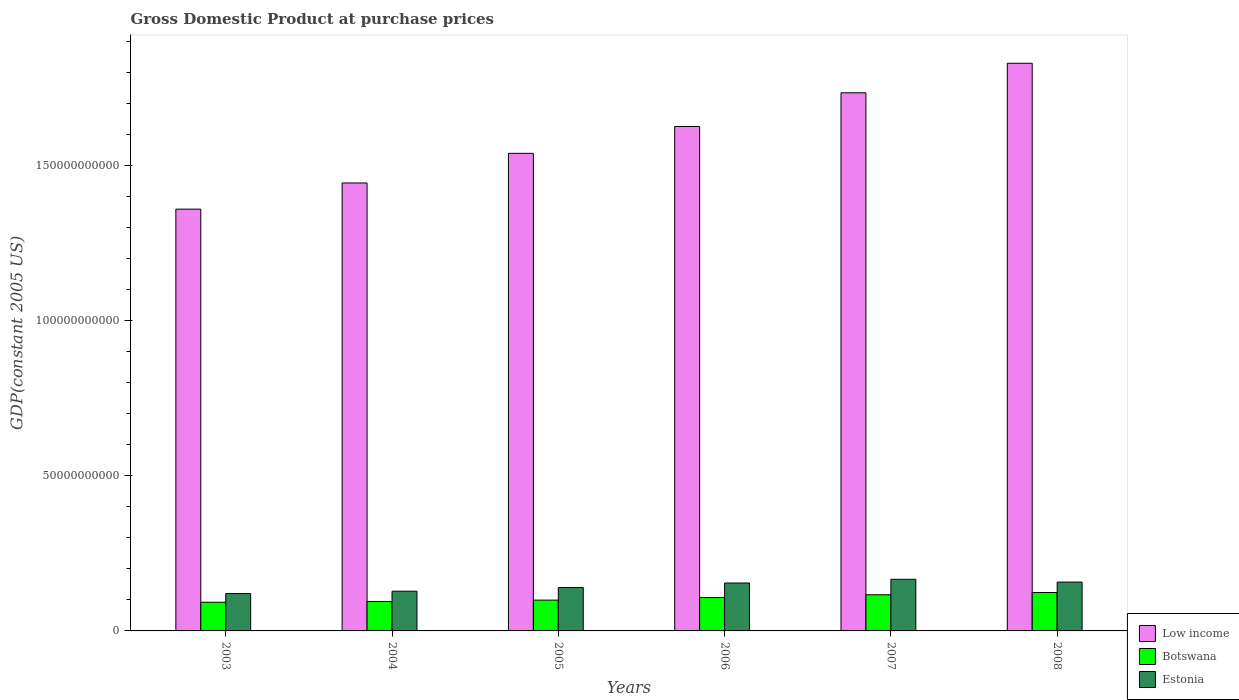How many different coloured bars are there?
Offer a terse response. 3. How many groups of bars are there?
Provide a short and direct response. 6. Are the number of bars per tick equal to the number of legend labels?
Keep it short and to the point. Yes. Are the number of bars on each tick of the X-axis equal?
Your answer should be compact. Yes. In how many cases, is the number of bars for a given year not equal to the number of legend labels?
Ensure brevity in your answer.  0. What is the GDP at purchase prices in Botswana in 2008?
Offer a very short reply. 1.24e+1. Across all years, what is the maximum GDP at purchase prices in Botswana?
Keep it short and to the point. 1.24e+1. Across all years, what is the minimum GDP at purchase prices in Botswana?
Your answer should be very brief. 9.25e+09. In which year was the GDP at purchase prices in Estonia minimum?
Keep it short and to the point. 2003. What is the total GDP at purchase prices in Estonia in the graph?
Ensure brevity in your answer.  8.67e+1. What is the difference between the GDP at purchase prices in Low income in 2003 and that in 2007?
Your answer should be very brief. -3.75e+1. What is the difference between the GDP at purchase prices in Botswana in 2007 and the GDP at purchase prices in Estonia in 2005?
Your answer should be compact. -2.35e+09. What is the average GDP at purchase prices in Botswana per year?
Ensure brevity in your answer.  1.06e+1. In the year 2005, what is the difference between the GDP at purchase prices in Low income and GDP at purchase prices in Estonia?
Ensure brevity in your answer.  1.40e+11. What is the ratio of the GDP at purchase prices in Low income in 2006 to that in 2007?
Make the answer very short. 0.94. Is the GDP at purchase prices in Low income in 2003 less than that in 2006?
Your response must be concise. Yes. What is the difference between the highest and the second highest GDP at purchase prices in Estonia?
Provide a short and direct response. 9.02e+08. What is the difference between the highest and the lowest GDP at purchase prices in Estonia?
Provide a succinct answer. 4.59e+09. Is the sum of the GDP at purchase prices in Low income in 2005 and 2006 greater than the maximum GDP at purchase prices in Botswana across all years?
Ensure brevity in your answer.  Yes. What does the 2nd bar from the left in 2005 represents?
Make the answer very short. Botswana. What does the 2nd bar from the right in 2007 represents?
Offer a very short reply. Botswana. How many years are there in the graph?
Offer a terse response. 6. Does the graph contain any zero values?
Provide a succinct answer. No. Does the graph contain grids?
Provide a short and direct response. No. How are the legend labels stacked?
Give a very brief answer. Vertical. What is the title of the graph?
Your answer should be compact. Gross Domestic Product at purchase prices. What is the label or title of the X-axis?
Your answer should be very brief. Years. What is the label or title of the Y-axis?
Give a very brief answer. GDP(constant 2005 US). What is the GDP(constant 2005 US) in Low income in 2003?
Provide a short and direct response. 1.36e+11. What is the GDP(constant 2005 US) of Botswana in 2003?
Ensure brevity in your answer.  9.25e+09. What is the GDP(constant 2005 US) in Estonia in 2003?
Provide a short and direct response. 1.20e+1. What is the GDP(constant 2005 US) of Low income in 2004?
Give a very brief answer. 1.44e+11. What is the GDP(constant 2005 US) of Botswana in 2004?
Give a very brief answer. 9.50e+09. What is the GDP(constant 2005 US) in Estonia in 2004?
Keep it short and to the point. 1.28e+1. What is the GDP(constant 2005 US) of Low income in 2005?
Your response must be concise. 1.54e+11. What is the GDP(constant 2005 US) in Botswana in 2005?
Provide a succinct answer. 9.93e+09. What is the GDP(constant 2005 US) of Estonia in 2005?
Your answer should be compact. 1.40e+1. What is the GDP(constant 2005 US) of Low income in 2006?
Your answer should be compact. 1.63e+11. What is the GDP(constant 2005 US) in Botswana in 2006?
Provide a short and direct response. 1.08e+1. What is the GDP(constant 2005 US) of Estonia in 2006?
Give a very brief answer. 1.54e+1. What is the GDP(constant 2005 US) in Low income in 2007?
Offer a very short reply. 1.73e+11. What is the GDP(constant 2005 US) in Botswana in 2007?
Offer a very short reply. 1.17e+1. What is the GDP(constant 2005 US) of Estonia in 2007?
Keep it short and to the point. 1.66e+1. What is the GDP(constant 2005 US) in Low income in 2008?
Offer a very short reply. 1.83e+11. What is the GDP(constant 2005 US) in Botswana in 2008?
Give a very brief answer. 1.24e+1. What is the GDP(constant 2005 US) of Estonia in 2008?
Provide a succinct answer. 1.57e+1. Across all years, what is the maximum GDP(constant 2005 US) of Low income?
Give a very brief answer. 1.83e+11. Across all years, what is the maximum GDP(constant 2005 US) in Botswana?
Offer a terse response. 1.24e+1. Across all years, what is the maximum GDP(constant 2005 US) in Estonia?
Make the answer very short. 1.66e+1. Across all years, what is the minimum GDP(constant 2005 US) of Low income?
Make the answer very short. 1.36e+11. Across all years, what is the minimum GDP(constant 2005 US) in Botswana?
Ensure brevity in your answer.  9.25e+09. Across all years, what is the minimum GDP(constant 2005 US) in Estonia?
Provide a succinct answer. 1.20e+1. What is the total GDP(constant 2005 US) in Low income in the graph?
Keep it short and to the point. 9.53e+11. What is the total GDP(constant 2005 US) in Botswana in the graph?
Provide a succinct answer. 6.35e+1. What is the total GDP(constant 2005 US) in Estonia in the graph?
Offer a terse response. 8.67e+1. What is the difference between the GDP(constant 2005 US) of Low income in 2003 and that in 2004?
Offer a terse response. -8.44e+09. What is the difference between the GDP(constant 2005 US) in Botswana in 2003 and that in 2004?
Your response must be concise. -2.50e+08. What is the difference between the GDP(constant 2005 US) in Estonia in 2003 and that in 2004?
Ensure brevity in your answer.  -7.58e+08. What is the difference between the GDP(constant 2005 US) in Low income in 2003 and that in 2005?
Make the answer very short. -1.80e+1. What is the difference between the GDP(constant 2005 US) of Botswana in 2003 and that in 2005?
Your answer should be compact. -6.83e+08. What is the difference between the GDP(constant 2005 US) of Estonia in 2003 and that in 2005?
Provide a short and direct response. -1.96e+09. What is the difference between the GDP(constant 2005 US) in Low income in 2003 and that in 2006?
Offer a terse response. -2.66e+1. What is the difference between the GDP(constant 2005 US) of Botswana in 2003 and that in 2006?
Give a very brief answer. -1.51e+09. What is the difference between the GDP(constant 2005 US) in Estonia in 2003 and that in 2006?
Your response must be concise. -3.40e+09. What is the difference between the GDP(constant 2005 US) in Low income in 2003 and that in 2007?
Keep it short and to the point. -3.75e+1. What is the difference between the GDP(constant 2005 US) of Botswana in 2003 and that in 2007?
Provide a short and direct response. -2.40e+09. What is the difference between the GDP(constant 2005 US) of Estonia in 2003 and that in 2007?
Your answer should be very brief. -4.59e+09. What is the difference between the GDP(constant 2005 US) of Low income in 2003 and that in 2008?
Your answer should be compact. -4.70e+1. What is the difference between the GDP(constant 2005 US) of Botswana in 2003 and that in 2008?
Ensure brevity in your answer.  -3.13e+09. What is the difference between the GDP(constant 2005 US) in Estonia in 2003 and that in 2008?
Provide a succinct answer. -3.69e+09. What is the difference between the GDP(constant 2005 US) of Low income in 2004 and that in 2005?
Ensure brevity in your answer.  -9.54e+09. What is the difference between the GDP(constant 2005 US) in Botswana in 2004 and that in 2005?
Your response must be concise. -4.33e+08. What is the difference between the GDP(constant 2005 US) in Estonia in 2004 and that in 2005?
Your answer should be very brief. -1.20e+09. What is the difference between the GDP(constant 2005 US) of Low income in 2004 and that in 2006?
Your answer should be very brief. -1.82e+1. What is the difference between the GDP(constant 2005 US) of Botswana in 2004 and that in 2006?
Provide a short and direct response. -1.26e+09. What is the difference between the GDP(constant 2005 US) in Estonia in 2004 and that in 2006?
Provide a short and direct response. -2.64e+09. What is the difference between the GDP(constant 2005 US) in Low income in 2004 and that in 2007?
Keep it short and to the point. -2.91e+1. What is the difference between the GDP(constant 2005 US) of Botswana in 2004 and that in 2007?
Give a very brief answer. -2.15e+09. What is the difference between the GDP(constant 2005 US) of Estonia in 2004 and that in 2007?
Provide a short and direct response. -3.84e+09. What is the difference between the GDP(constant 2005 US) of Low income in 2004 and that in 2008?
Your answer should be very brief. -3.86e+1. What is the difference between the GDP(constant 2005 US) in Botswana in 2004 and that in 2008?
Your answer should be very brief. -2.88e+09. What is the difference between the GDP(constant 2005 US) of Estonia in 2004 and that in 2008?
Your response must be concise. -2.93e+09. What is the difference between the GDP(constant 2005 US) of Low income in 2005 and that in 2006?
Your response must be concise. -8.66e+09. What is the difference between the GDP(constant 2005 US) of Botswana in 2005 and that in 2006?
Provide a short and direct response. -8.31e+08. What is the difference between the GDP(constant 2005 US) of Estonia in 2005 and that in 2006?
Make the answer very short. -1.44e+09. What is the difference between the GDP(constant 2005 US) in Low income in 2005 and that in 2007?
Keep it short and to the point. -1.95e+1. What is the difference between the GDP(constant 2005 US) of Botswana in 2005 and that in 2007?
Provide a short and direct response. -1.72e+09. What is the difference between the GDP(constant 2005 US) in Estonia in 2005 and that in 2007?
Your answer should be compact. -2.64e+09. What is the difference between the GDP(constant 2005 US) in Low income in 2005 and that in 2008?
Your response must be concise. -2.90e+1. What is the difference between the GDP(constant 2005 US) of Botswana in 2005 and that in 2008?
Make the answer very short. -2.45e+09. What is the difference between the GDP(constant 2005 US) of Estonia in 2005 and that in 2008?
Offer a terse response. -1.73e+09. What is the difference between the GDP(constant 2005 US) of Low income in 2006 and that in 2007?
Make the answer very short. -1.09e+1. What is the difference between the GDP(constant 2005 US) in Botswana in 2006 and that in 2007?
Offer a terse response. -8.91e+08. What is the difference between the GDP(constant 2005 US) in Estonia in 2006 and that in 2007?
Offer a very short reply. -1.20e+09. What is the difference between the GDP(constant 2005 US) of Low income in 2006 and that in 2008?
Keep it short and to the point. -2.04e+1. What is the difference between the GDP(constant 2005 US) in Botswana in 2006 and that in 2008?
Ensure brevity in your answer.  -1.62e+09. What is the difference between the GDP(constant 2005 US) of Estonia in 2006 and that in 2008?
Offer a terse response. -2.95e+08. What is the difference between the GDP(constant 2005 US) of Low income in 2007 and that in 2008?
Give a very brief answer. -9.52e+09. What is the difference between the GDP(constant 2005 US) of Botswana in 2007 and that in 2008?
Make the answer very short. -7.27e+08. What is the difference between the GDP(constant 2005 US) of Estonia in 2007 and that in 2008?
Give a very brief answer. 9.02e+08. What is the difference between the GDP(constant 2005 US) in Low income in 2003 and the GDP(constant 2005 US) in Botswana in 2004?
Make the answer very short. 1.26e+11. What is the difference between the GDP(constant 2005 US) of Low income in 2003 and the GDP(constant 2005 US) of Estonia in 2004?
Make the answer very short. 1.23e+11. What is the difference between the GDP(constant 2005 US) in Botswana in 2003 and the GDP(constant 2005 US) in Estonia in 2004?
Offer a very short reply. -3.56e+09. What is the difference between the GDP(constant 2005 US) in Low income in 2003 and the GDP(constant 2005 US) in Botswana in 2005?
Give a very brief answer. 1.26e+11. What is the difference between the GDP(constant 2005 US) of Low income in 2003 and the GDP(constant 2005 US) of Estonia in 2005?
Keep it short and to the point. 1.22e+11. What is the difference between the GDP(constant 2005 US) of Botswana in 2003 and the GDP(constant 2005 US) of Estonia in 2005?
Ensure brevity in your answer.  -4.76e+09. What is the difference between the GDP(constant 2005 US) in Low income in 2003 and the GDP(constant 2005 US) in Botswana in 2006?
Your answer should be very brief. 1.25e+11. What is the difference between the GDP(constant 2005 US) in Low income in 2003 and the GDP(constant 2005 US) in Estonia in 2006?
Give a very brief answer. 1.21e+11. What is the difference between the GDP(constant 2005 US) in Botswana in 2003 and the GDP(constant 2005 US) in Estonia in 2006?
Your response must be concise. -6.20e+09. What is the difference between the GDP(constant 2005 US) in Low income in 2003 and the GDP(constant 2005 US) in Botswana in 2007?
Provide a succinct answer. 1.24e+11. What is the difference between the GDP(constant 2005 US) of Low income in 2003 and the GDP(constant 2005 US) of Estonia in 2007?
Make the answer very short. 1.19e+11. What is the difference between the GDP(constant 2005 US) of Botswana in 2003 and the GDP(constant 2005 US) of Estonia in 2007?
Provide a succinct answer. -7.39e+09. What is the difference between the GDP(constant 2005 US) of Low income in 2003 and the GDP(constant 2005 US) of Botswana in 2008?
Provide a succinct answer. 1.24e+11. What is the difference between the GDP(constant 2005 US) in Low income in 2003 and the GDP(constant 2005 US) in Estonia in 2008?
Keep it short and to the point. 1.20e+11. What is the difference between the GDP(constant 2005 US) in Botswana in 2003 and the GDP(constant 2005 US) in Estonia in 2008?
Give a very brief answer. -6.49e+09. What is the difference between the GDP(constant 2005 US) of Low income in 2004 and the GDP(constant 2005 US) of Botswana in 2005?
Provide a short and direct response. 1.34e+11. What is the difference between the GDP(constant 2005 US) of Low income in 2004 and the GDP(constant 2005 US) of Estonia in 2005?
Ensure brevity in your answer.  1.30e+11. What is the difference between the GDP(constant 2005 US) of Botswana in 2004 and the GDP(constant 2005 US) of Estonia in 2005?
Offer a very short reply. -4.51e+09. What is the difference between the GDP(constant 2005 US) in Low income in 2004 and the GDP(constant 2005 US) in Botswana in 2006?
Keep it short and to the point. 1.34e+11. What is the difference between the GDP(constant 2005 US) in Low income in 2004 and the GDP(constant 2005 US) in Estonia in 2006?
Provide a succinct answer. 1.29e+11. What is the difference between the GDP(constant 2005 US) in Botswana in 2004 and the GDP(constant 2005 US) in Estonia in 2006?
Provide a succinct answer. -5.95e+09. What is the difference between the GDP(constant 2005 US) in Low income in 2004 and the GDP(constant 2005 US) in Botswana in 2007?
Provide a short and direct response. 1.33e+11. What is the difference between the GDP(constant 2005 US) in Low income in 2004 and the GDP(constant 2005 US) in Estonia in 2007?
Provide a succinct answer. 1.28e+11. What is the difference between the GDP(constant 2005 US) of Botswana in 2004 and the GDP(constant 2005 US) of Estonia in 2007?
Offer a very short reply. -7.14e+09. What is the difference between the GDP(constant 2005 US) in Low income in 2004 and the GDP(constant 2005 US) in Botswana in 2008?
Provide a succinct answer. 1.32e+11. What is the difference between the GDP(constant 2005 US) in Low income in 2004 and the GDP(constant 2005 US) in Estonia in 2008?
Offer a terse response. 1.29e+11. What is the difference between the GDP(constant 2005 US) of Botswana in 2004 and the GDP(constant 2005 US) of Estonia in 2008?
Offer a very short reply. -6.24e+09. What is the difference between the GDP(constant 2005 US) of Low income in 2005 and the GDP(constant 2005 US) of Botswana in 2006?
Your response must be concise. 1.43e+11. What is the difference between the GDP(constant 2005 US) in Low income in 2005 and the GDP(constant 2005 US) in Estonia in 2006?
Your answer should be compact. 1.39e+11. What is the difference between the GDP(constant 2005 US) of Botswana in 2005 and the GDP(constant 2005 US) of Estonia in 2006?
Give a very brief answer. -5.51e+09. What is the difference between the GDP(constant 2005 US) of Low income in 2005 and the GDP(constant 2005 US) of Botswana in 2007?
Ensure brevity in your answer.  1.42e+11. What is the difference between the GDP(constant 2005 US) in Low income in 2005 and the GDP(constant 2005 US) in Estonia in 2007?
Give a very brief answer. 1.37e+11. What is the difference between the GDP(constant 2005 US) of Botswana in 2005 and the GDP(constant 2005 US) of Estonia in 2007?
Your response must be concise. -6.71e+09. What is the difference between the GDP(constant 2005 US) in Low income in 2005 and the GDP(constant 2005 US) in Botswana in 2008?
Provide a short and direct response. 1.42e+11. What is the difference between the GDP(constant 2005 US) in Low income in 2005 and the GDP(constant 2005 US) in Estonia in 2008?
Provide a succinct answer. 1.38e+11. What is the difference between the GDP(constant 2005 US) in Botswana in 2005 and the GDP(constant 2005 US) in Estonia in 2008?
Your response must be concise. -5.81e+09. What is the difference between the GDP(constant 2005 US) of Low income in 2006 and the GDP(constant 2005 US) of Botswana in 2007?
Provide a succinct answer. 1.51e+11. What is the difference between the GDP(constant 2005 US) of Low income in 2006 and the GDP(constant 2005 US) of Estonia in 2007?
Make the answer very short. 1.46e+11. What is the difference between the GDP(constant 2005 US) of Botswana in 2006 and the GDP(constant 2005 US) of Estonia in 2007?
Offer a terse response. -5.88e+09. What is the difference between the GDP(constant 2005 US) of Low income in 2006 and the GDP(constant 2005 US) of Botswana in 2008?
Provide a short and direct response. 1.50e+11. What is the difference between the GDP(constant 2005 US) of Low income in 2006 and the GDP(constant 2005 US) of Estonia in 2008?
Ensure brevity in your answer.  1.47e+11. What is the difference between the GDP(constant 2005 US) in Botswana in 2006 and the GDP(constant 2005 US) in Estonia in 2008?
Make the answer very short. -4.98e+09. What is the difference between the GDP(constant 2005 US) in Low income in 2007 and the GDP(constant 2005 US) in Botswana in 2008?
Give a very brief answer. 1.61e+11. What is the difference between the GDP(constant 2005 US) of Low income in 2007 and the GDP(constant 2005 US) of Estonia in 2008?
Give a very brief answer. 1.58e+11. What is the difference between the GDP(constant 2005 US) in Botswana in 2007 and the GDP(constant 2005 US) in Estonia in 2008?
Keep it short and to the point. -4.09e+09. What is the average GDP(constant 2005 US) of Low income per year?
Give a very brief answer. 1.59e+11. What is the average GDP(constant 2005 US) of Botswana per year?
Provide a succinct answer. 1.06e+1. What is the average GDP(constant 2005 US) in Estonia per year?
Make the answer very short. 1.44e+1. In the year 2003, what is the difference between the GDP(constant 2005 US) of Low income and GDP(constant 2005 US) of Botswana?
Offer a terse response. 1.27e+11. In the year 2003, what is the difference between the GDP(constant 2005 US) of Low income and GDP(constant 2005 US) of Estonia?
Give a very brief answer. 1.24e+11. In the year 2003, what is the difference between the GDP(constant 2005 US) in Botswana and GDP(constant 2005 US) in Estonia?
Make the answer very short. -2.80e+09. In the year 2004, what is the difference between the GDP(constant 2005 US) in Low income and GDP(constant 2005 US) in Botswana?
Your answer should be very brief. 1.35e+11. In the year 2004, what is the difference between the GDP(constant 2005 US) of Low income and GDP(constant 2005 US) of Estonia?
Provide a succinct answer. 1.32e+11. In the year 2004, what is the difference between the GDP(constant 2005 US) of Botswana and GDP(constant 2005 US) of Estonia?
Provide a short and direct response. -3.31e+09. In the year 2005, what is the difference between the GDP(constant 2005 US) of Low income and GDP(constant 2005 US) of Botswana?
Keep it short and to the point. 1.44e+11. In the year 2005, what is the difference between the GDP(constant 2005 US) in Low income and GDP(constant 2005 US) in Estonia?
Your response must be concise. 1.40e+11. In the year 2005, what is the difference between the GDP(constant 2005 US) of Botswana and GDP(constant 2005 US) of Estonia?
Make the answer very short. -4.07e+09. In the year 2006, what is the difference between the GDP(constant 2005 US) in Low income and GDP(constant 2005 US) in Botswana?
Offer a terse response. 1.52e+11. In the year 2006, what is the difference between the GDP(constant 2005 US) in Low income and GDP(constant 2005 US) in Estonia?
Offer a very short reply. 1.47e+11. In the year 2006, what is the difference between the GDP(constant 2005 US) of Botswana and GDP(constant 2005 US) of Estonia?
Make the answer very short. -4.68e+09. In the year 2007, what is the difference between the GDP(constant 2005 US) of Low income and GDP(constant 2005 US) of Botswana?
Your answer should be very brief. 1.62e+11. In the year 2007, what is the difference between the GDP(constant 2005 US) in Low income and GDP(constant 2005 US) in Estonia?
Make the answer very short. 1.57e+11. In the year 2007, what is the difference between the GDP(constant 2005 US) in Botswana and GDP(constant 2005 US) in Estonia?
Give a very brief answer. -4.99e+09. In the year 2008, what is the difference between the GDP(constant 2005 US) of Low income and GDP(constant 2005 US) of Botswana?
Ensure brevity in your answer.  1.71e+11. In the year 2008, what is the difference between the GDP(constant 2005 US) in Low income and GDP(constant 2005 US) in Estonia?
Offer a very short reply. 1.67e+11. In the year 2008, what is the difference between the GDP(constant 2005 US) of Botswana and GDP(constant 2005 US) of Estonia?
Your response must be concise. -3.36e+09. What is the ratio of the GDP(constant 2005 US) in Low income in 2003 to that in 2004?
Your answer should be compact. 0.94. What is the ratio of the GDP(constant 2005 US) in Botswana in 2003 to that in 2004?
Ensure brevity in your answer.  0.97. What is the ratio of the GDP(constant 2005 US) of Estonia in 2003 to that in 2004?
Your answer should be very brief. 0.94. What is the ratio of the GDP(constant 2005 US) in Low income in 2003 to that in 2005?
Your answer should be compact. 0.88. What is the ratio of the GDP(constant 2005 US) in Botswana in 2003 to that in 2005?
Give a very brief answer. 0.93. What is the ratio of the GDP(constant 2005 US) of Estonia in 2003 to that in 2005?
Provide a short and direct response. 0.86. What is the ratio of the GDP(constant 2005 US) in Low income in 2003 to that in 2006?
Provide a short and direct response. 0.84. What is the ratio of the GDP(constant 2005 US) of Botswana in 2003 to that in 2006?
Your answer should be very brief. 0.86. What is the ratio of the GDP(constant 2005 US) in Estonia in 2003 to that in 2006?
Provide a short and direct response. 0.78. What is the ratio of the GDP(constant 2005 US) in Low income in 2003 to that in 2007?
Provide a succinct answer. 0.78. What is the ratio of the GDP(constant 2005 US) of Botswana in 2003 to that in 2007?
Your answer should be compact. 0.79. What is the ratio of the GDP(constant 2005 US) in Estonia in 2003 to that in 2007?
Offer a terse response. 0.72. What is the ratio of the GDP(constant 2005 US) in Low income in 2003 to that in 2008?
Give a very brief answer. 0.74. What is the ratio of the GDP(constant 2005 US) of Botswana in 2003 to that in 2008?
Keep it short and to the point. 0.75. What is the ratio of the GDP(constant 2005 US) in Estonia in 2003 to that in 2008?
Make the answer very short. 0.77. What is the ratio of the GDP(constant 2005 US) in Low income in 2004 to that in 2005?
Ensure brevity in your answer.  0.94. What is the ratio of the GDP(constant 2005 US) in Botswana in 2004 to that in 2005?
Make the answer very short. 0.96. What is the ratio of the GDP(constant 2005 US) in Estonia in 2004 to that in 2005?
Your response must be concise. 0.91. What is the ratio of the GDP(constant 2005 US) in Low income in 2004 to that in 2006?
Ensure brevity in your answer.  0.89. What is the ratio of the GDP(constant 2005 US) in Botswana in 2004 to that in 2006?
Offer a terse response. 0.88. What is the ratio of the GDP(constant 2005 US) in Estonia in 2004 to that in 2006?
Offer a very short reply. 0.83. What is the ratio of the GDP(constant 2005 US) in Low income in 2004 to that in 2007?
Give a very brief answer. 0.83. What is the ratio of the GDP(constant 2005 US) in Botswana in 2004 to that in 2007?
Keep it short and to the point. 0.82. What is the ratio of the GDP(constant 2005 US) in Estonia in 2004 to that in 2007?
Your answer should be very brief. 0.77. What is the ratio of the GDP(constant 2005 US) in Low income in 2004 to that in 2008?
Keep it short and to the point. 0.79. What is the ratio of the GDP(constant 2005 US) of Botswana in 2004 to that in 2008?
Provide a short and direct response. 0.77. What is the ratio of the GDP(constant 2005 US) in Estonia in 2004 to that in 2008?
Offer a terse response. 0.81. What is the ratio of the GDP(constant 2005 US) in Low income in 2005 to that in 2006?
Provide a succinct answer. 0.95. What is the ratio of the GDP(constant 2005 US) of Botswana in 2005 to that in 2006?
Your response must be concise. 0.92. What is the ratio of the GDP(constant 2005 US) of Estonia in 2005 to that in 2006?
Your answer should be compact. 0.91. What is the ratio of the GDP(constant 2005 US) in Low income in 2005 to that in 2007?
Make the answer very short. 0.89. What is the ratio of the GDP(constant 2005 US) in Botswana in 2005 to that in 2007?
Provide a short and direct response. 0.85. What is the ratio of the GDP(constant 2005 US) in Estonia in 2005 to that in 2007?
Your answer should be very brief. 0.84. What is the ratio of the GDP(constant 2005 US) in Low income in 2005 to that in 2008?
Give a very brief answer. 0.84. What is the ratio of the GDP(constant 2005 US) of Botswana in 2005 to that in 2008?
Provide a short and direct response. 0.8. What is the ratio of the GDP(constant 2005 US) of Estonia in 2005 to that in 2008?
Provide a short and direct response. 0.89. What is the ratio of the GDP(constant 2005 US) of Low income in 2006 to that in 2007?
Provide a short and direct response. 0.94. What is the ratio of the GDP(constant 2005 US) of Botswana in 2006 to that in 2007?
Your answer should be compact. 0.92. What is the ratio of the GDP(constant 2005 US) of Estonia in 2006 to that in 2007?
Ensure brevity in your answer.  0.93. What is the ratio of the GDP(constant 2005 US) in Low income in 2006 to that in 2008?
Provide a short and direct response. 0.89. What is the ratio of the GDP(constant 2005 US) in Botswana in 2006 to that in 2008?
Give a very brief answer. 0.87. What is the ratio of the GDP(constant 2005 US) of Estonia in 2006 to that in 2008?
Provide a succinct answer. 0.98. What is the ratio of the GDP(constant 2005 US) in Low income in 2007 to that in 2008?
Give a very brief answer. 0.95. What is the ratio of the GDP(constant 2005 US) of Botswana in 2007 to that in 2008?
Provide a short and direct response. 0.94. What is the ratio of the GDP(constant 2005 US) in Estonia in 2007 to that in 2008?
Keep it short and to the point. 1.06. What is the difference between the highest and the second highest GDP(constant 2005 US) in Low income?
Your answer should be very brief. 9.52e+09. What is the difference between the highest and the second highest GDP(constant 2005 US) of Botswana?
Provide a succinct answer. 7.27e+08. What is the difference between the highest and the second highest GDP(constant 2005 US) of Estonia?
Offer a terse response. 9.02e+08. What is the difference between the highest and the lowest GDP(constant 2005 US) of Low income?
Offer a very short reply. 4.70e+1. What is the difference between the highest and the lowest GDP(constant 2005 US) in Botswana?
Your answer should be very brief. 3.13e+09. What is the difference between the highest and the lowest GDP(constant 2005 US) of Estonia?
Give a very brief answer. 4.59e+09. 